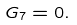Convert formula to latex. <formula><loc_0><loc_0><loc_500><loc_500>G _ { 7 } = 0 .</formula> 